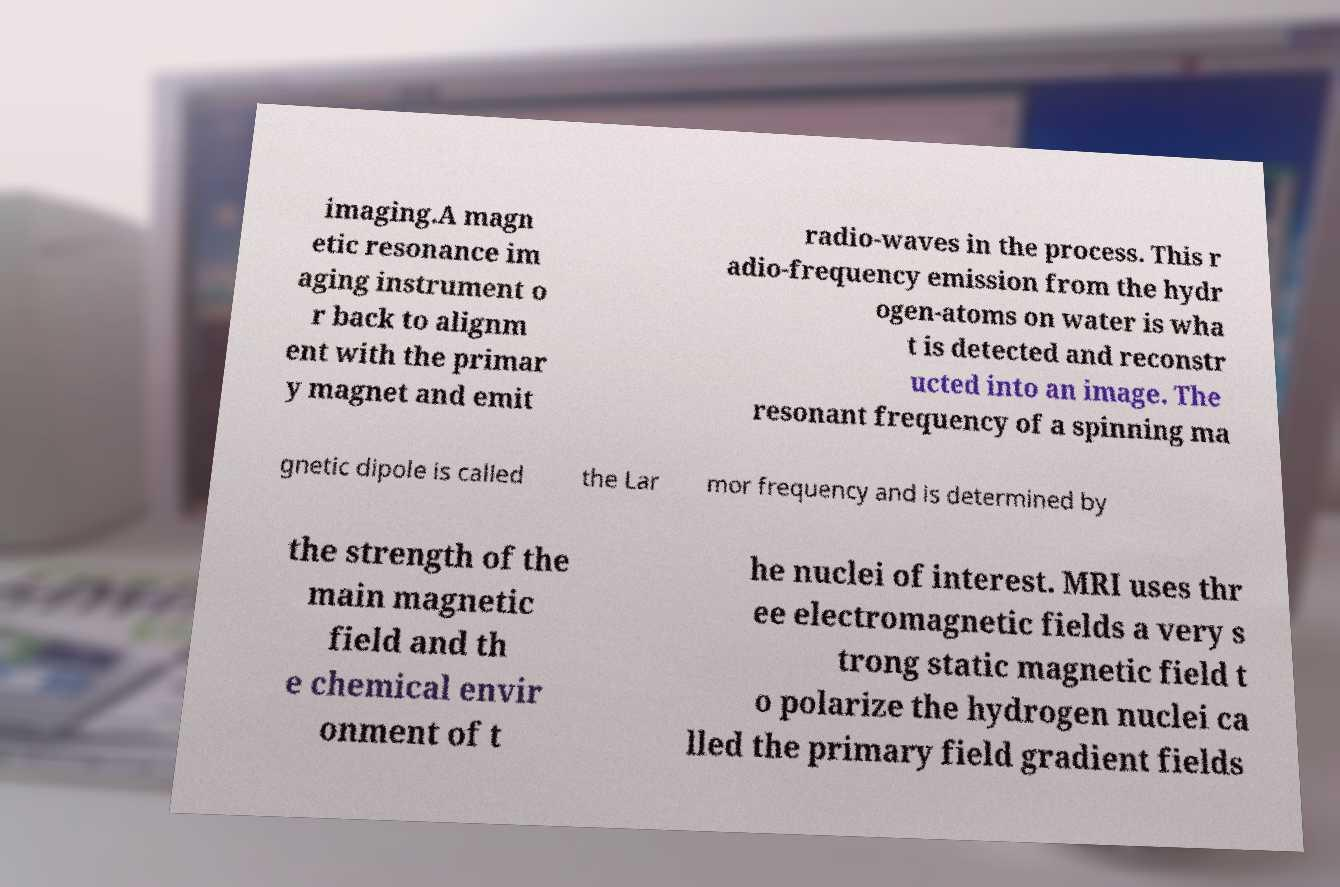For documentation purposes, I need the text within this image transcribed. Could you provide that? imaging.A magn etic resonance im aging instrument o r back to alignm ent with the primar y magnet and emit radio-waves in the process. This r adio-frequency emission from the hydr ogen-atoms on water is wha t is detected and reconstr ucted into an image. The resonant frequency of a spinning ma gnetic dipole is called the Lar mor frequency and is determined by the strength of the main magnetic field and th e chemical envir onment of t he nuclei of interest. MRI uses thr ee electromagnetic fields a very s trong static magnetic field t o polarize the hydrogen nuclei ca lled the primary field gradient fields 